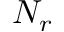Convert formula to latex. <formula><loc_0><loc_0><loc_500><loc_500>N _ { r }</formula> 